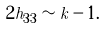Convert formula to latex. <formula><loc_0><loc_0><loc_500><loc_500>2 h _ { 3 3 } \sim k - 1 .</formula> 